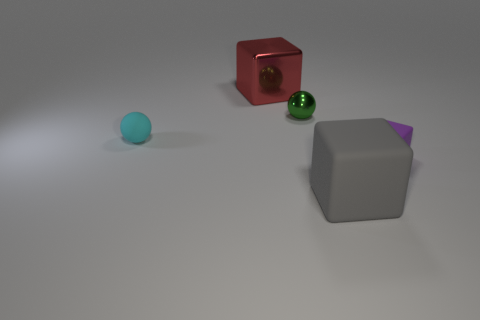What material is the green sphere that is the same size as the purple rubber object?
Provide a succinct answer. Metal. How many other things are the same material as the tiny purple cube?
Give a very brief answer. 2. There is a thing that is to the right of the red cube and behind the cyan sphere; what color is it?
Offer a very short reply. Green. How many objects are large things behind the purple object or metallic balls?
Provide a succinct answer. 2. How many other things are there of the same color as the large matte block?
Make the answer very short. 0. Are there the same number of tiny balls that are right of the red thing and gray cubes?
Your answer should be compact. Yes. There is a matte block that is in front of the tiny rubber object right of the tiny green shiny sphere; how many green metallic balls are behind it?
Offer a very short reply. 1. Is there any other thing that is the same size as the cyan ball?
Offer a terse response. Yes. There is a cyan sphere; does it have the same size as the shiny thing that is on the right side of the big red metal block?
Provide a short and direct response. Yes. What number of matte objects are there?
Give a very brief answer. 3. 